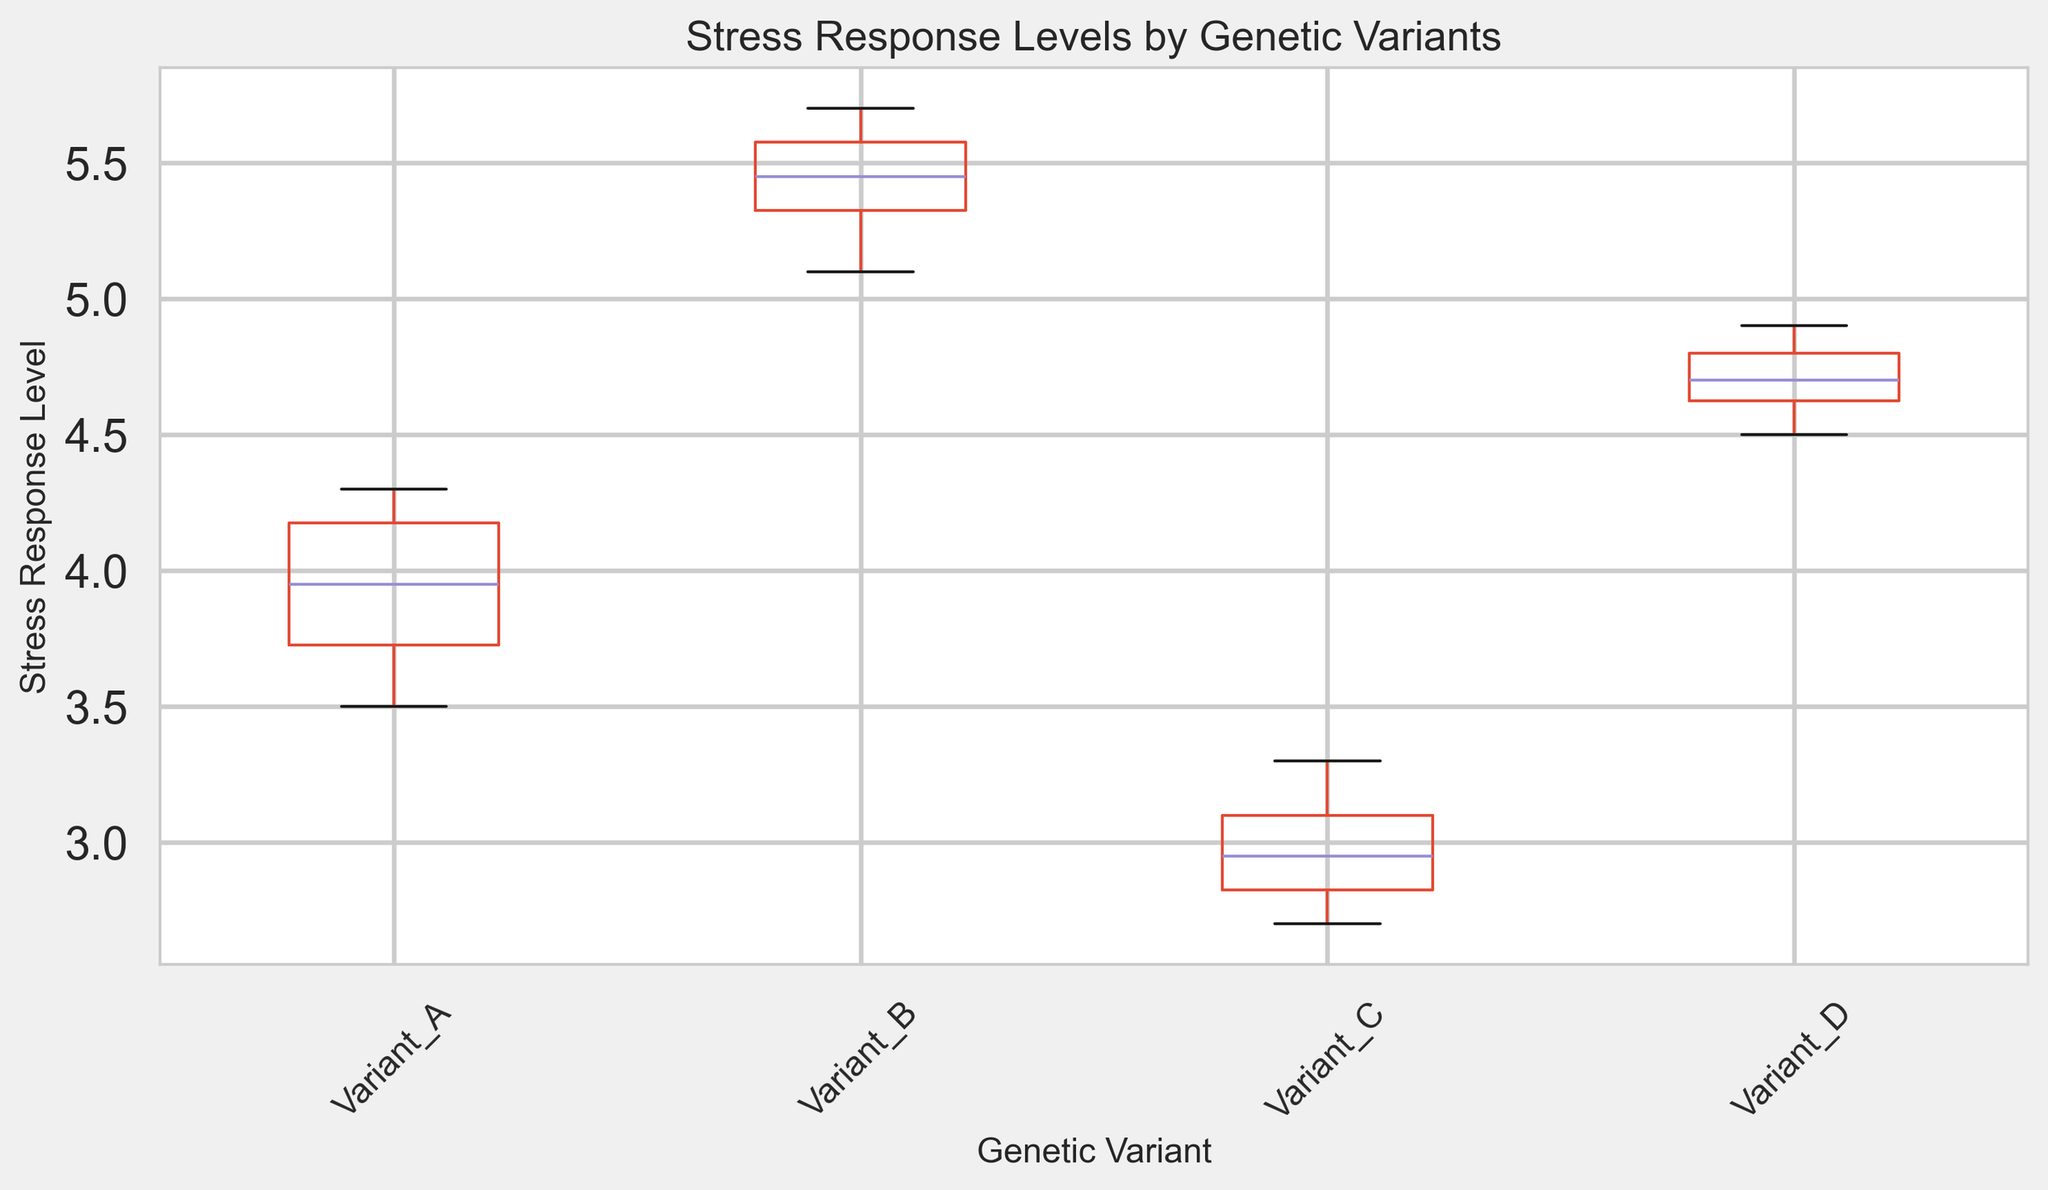What is the median stress response level for Variant A? The median is the middle value when the data points are arranged in ascending order. For Variant A, the values are [3.5, 3.6, 3.7, 3.8, 3.9, 4.0, 4.1, 4.2, 4.2, 4.3]. With 10 data points, the median is the average of the 5th and 6th values: (3.9 + 4.0) / 2 = 3.95.
Answer: 3.95 Which genetic variant has the highest median stress response level? To find the highest median stress response level, compare the medians of the four variants. Based on the box plot, Variant B has the highest median as its center line is higher than the medians of the other variants.
Answer: Variant B What is the interquartile range (IQR) for Variant D? The IQR is the difference between the 75th percentile (upper quartile) and the 25th percentile (lower quartile) values. From the box plot, the lower quartile (Q1) for Variant D is around 4.6, and the upper quartile (Q3) is around 4.8. Hence, IQR = 4.8 - 4.6 = 0.2.
Answer: 0.2 Which variant has the lowest maximum stress response level? The maximum stress response level is the top end of the whisker for each box plot. Variant C has the lowest maximum stress response level, which appears to be around 3.3.
Answer: Variant C Compare the spread of stress response levels between Variant A and Variant D. The spread (range) of stress response levels can be seen by comparing the length of the boxes and whiskers. Variant A's spread ranges from ~3.5 to ~4.3 (range = 0.8), and Variant D's spread ranges from ~4.5 to ~4.9 (range = 0.4), indicating that Variant A has a wider spread than Variant D.
Answer: Variant A has a wider spread What is the range (maximum minus minimum) of stress response levels for Variant B? From the box plot, the maximum value of Variant B is ~5.7 and the minimum value is ~5.1. The range is therefore 5.7 - 5.1 = 0.6.
Answer: 0.6 Which genetic variant appears to have the most outliers? Outliers are indicated by the red dots outside the whiskers in the box plot. Observing the plot, most of the genetic variants do not have noticeable outliers, but if any red dots are present, that variant would have outliers.
Answer: None or not visibly distinguishable What can you say about the variation in stress response levels among the different genetic variants? The variation can be inferred by comparing the heights of the boxes and whiskers for each variant. Variants A and B have larger boxes than D, indicating more variability. Variant C has the smallest box, suggesting the least variation in stress response levels.
Answer: A and B show more variability; C shows the least 